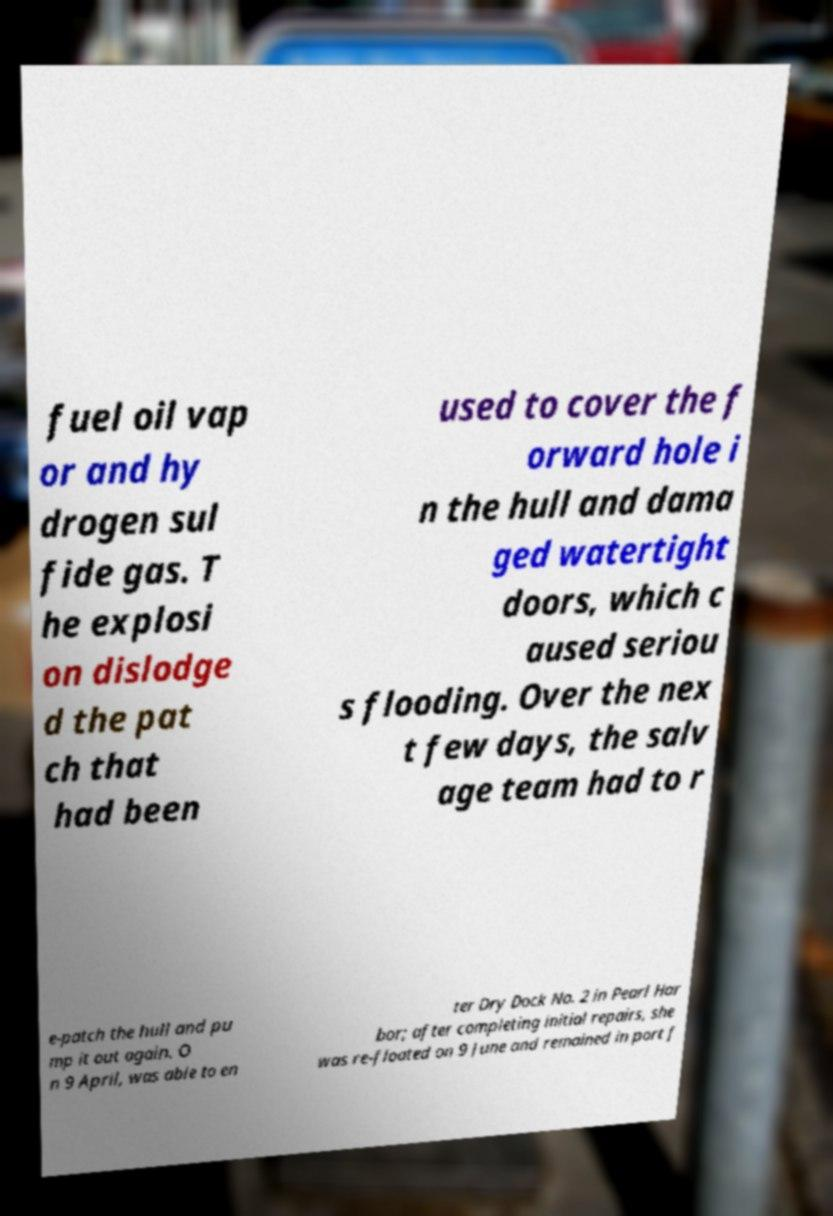There's text embedded in this image that I need extracted. Can you transcribe it verbatim? fuel oil vap or and hy drogen sul fide gas. T he explosi on dislodge d the pat ch that had been used to cover the f orward hole i n the hull and dama ged watertight doors, which c aused seriou s flooding. Over the nex t few days, the salv age team had to r e-patch the hull and pu mp it out again. O n 9 April, was able to en ter Dry Dock No. 2 in Pearl Har bor; after completing initial repairs, she was re-floated on 9 June and remained in port f 